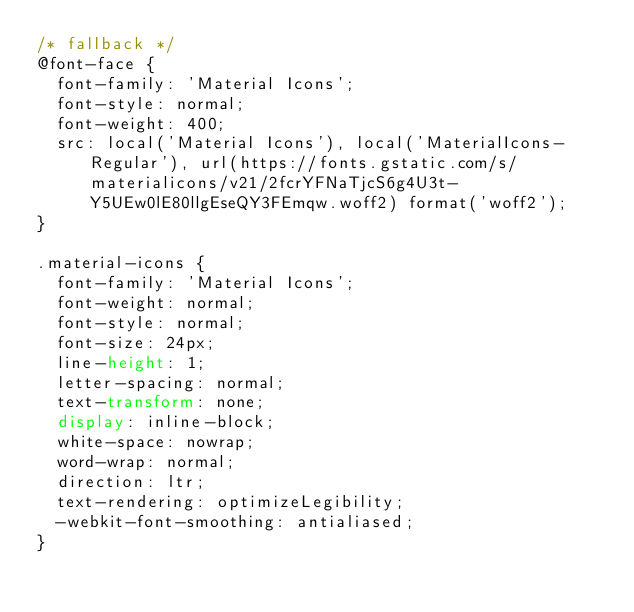<code> <loc_0><loc_0><loc_500><loc_500><_CSS_>/* fallback */
@font-face {
  font-family: 'Material Icons';
  font-style: normal;
  font-weight: 400;
  src: local('Material Icons'), local('MaterialIcons-Regular'), url(https://fonts.gstatic.com/s/materialicons/v21/2fcrYFNaTjcS6g4U3t-Y5UEw0lE80llgEseQY3FEmqw.woff2) format('woff2');
}

.material-icons {
  font-family: 'Material Icons';
  font-weight: normal;
  font-style: normal;
  font-size: 24px;
  line-height: 1;
  letter-spacing: normal;
  text-transform: none;
  display: inline-block;
  white-space: nowrap;
  word-wrap: normal;
  direction: ltr;
  text-rendering: optimizeLegibility;
  -webkit-font-smoothing: antialiased;
}
</code> 